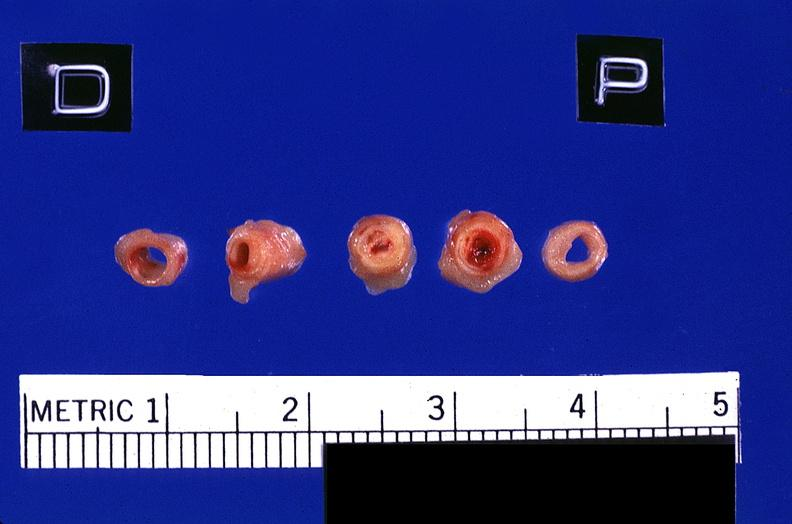what is present?
Answer the question using a single word or phrase. Cardiovascular 